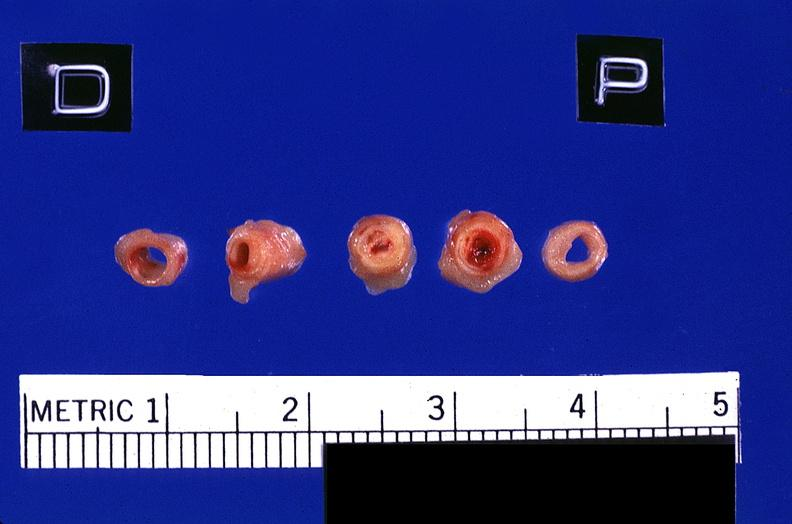what is present?
Answer the question using a single word or phrase. Cardiovascular 